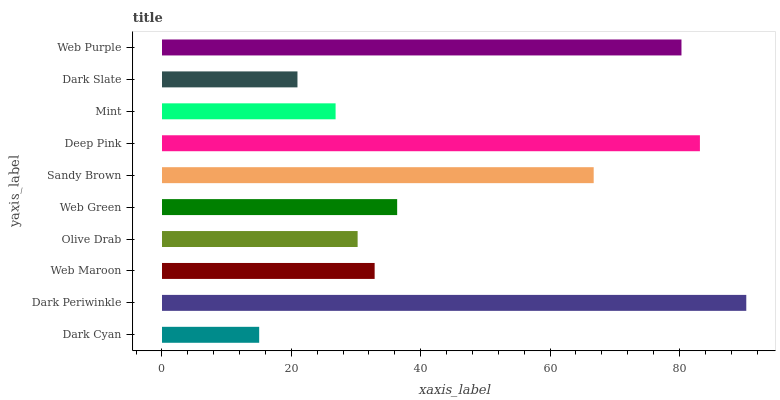Is Dark Cyan the minimum?
Answer yes or no. Yes. Is Dark Periwinkle the maximum?
Answer yes or no. Yes. Is Web Maroon the minimum?
Answer yes or no. No. Is Web Maroon the maximum?
Answer yes or no. No. Is Dark Periwinkle greater than Web Maroon?
Answer yes or no. Yes. Is Web Maroon less than Dark Periwinkle?
Answer yes or no. Yes. Is Web Maroon greater than Dark Periwinkle?
Answer yes or no. No. Is Dark Periwinkle less than Web Maroon?
Answer yes or no. No. Is Web Green the high median?
Answer yes or no. Yes. Is Web Maroon the low median?
Answer yes or no. Yes. Is Mint the high median?
Answer yes or no. No. Is Dark Slate the low median?
Answer yes or no. No. 